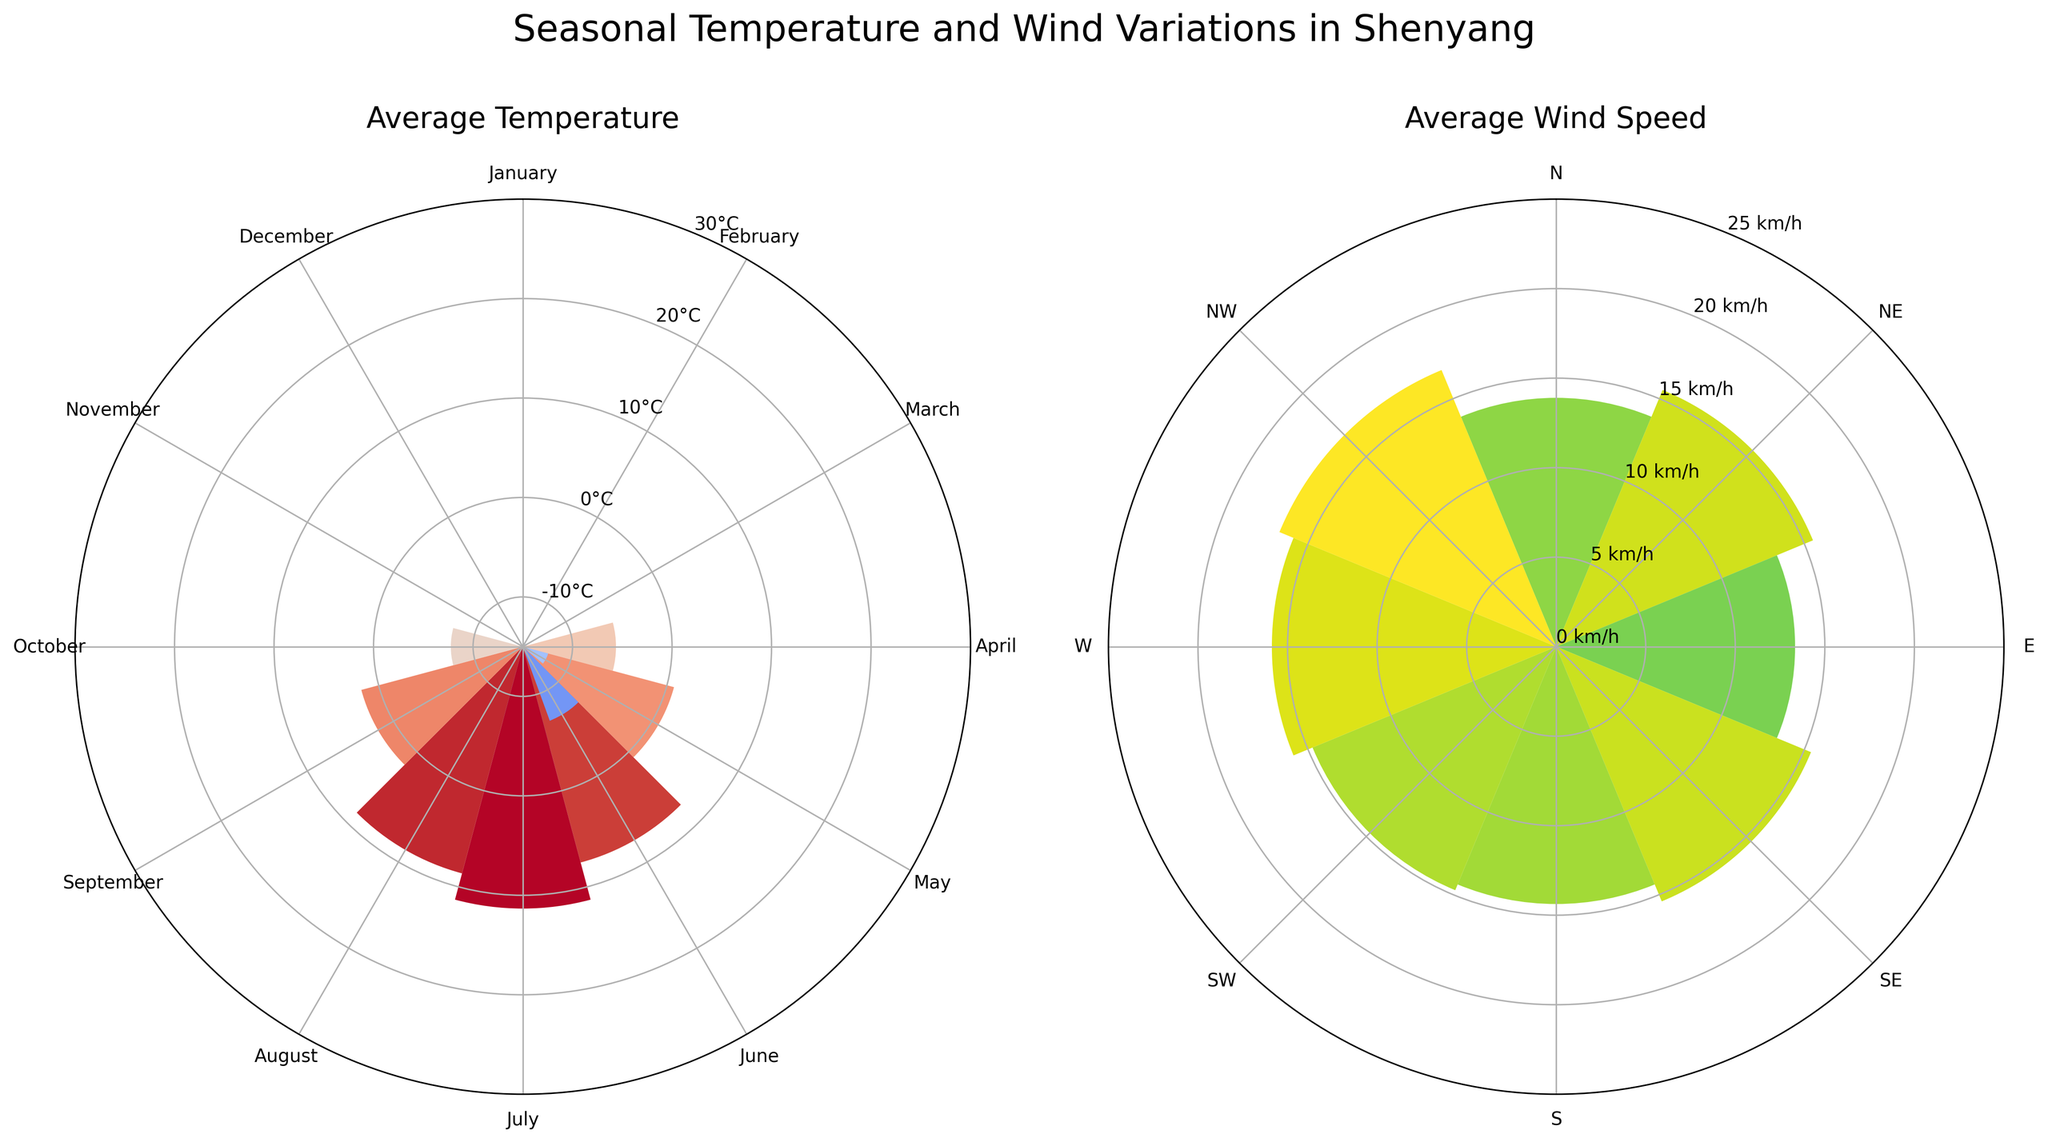What is the title of the figure? The title is located at the top of the figure and is clearly labeled.
Answer: Seasonal Temperature and Wind Variations in Shenyang Which month has the highest average temperature? Looking at the temperature rose chart, July has the longest bar indicating the highest average temperature.
Answer: July What is the average wind speed in the northern direction? Looking at the wind rose chart, the bar for the 'N' direction shows around 14 km/h.
Answer: 14 km/h Which month shows the lowest average temperature? The shortest bar in the temperature rose chart corresponds to January, indicating the lowest average temperature.
Answer: January How many months have an average temperature above 20°C? Identifying bars that exceed the 20°C mark in the temperature rose chart, there are three months: June, July, and August.
Answer: 3 Which direction has the lowest average wind speed? Observing the wind rose chart, the 'S' direction has the shortest bar, indicating the lowest average wind speed.
Answer: S What is the range of average temperatures shown in the temperature rose chart? The range is the difference between the highest and lowest values. From the chart, the highest is around 27°C (July) and the lowest is around -10.5°C (January), giving a range of 37.5°C.
Answer: 37.5°C Which month has the most variation in wind direction? Observing the number of different wind directions for each month, March shows the maximum number of different wind directions with noticeable bars in the wind rose chart.
Answer: March Compare the average wind speeds in March and June. Which month has higher wind speeds? March shows wind speeds around 20 km/h, while June shows wind speeds around 18 km/h in the wind rose chart. March has higher wind speeds.
Answer: March During which month does the direction 'NE' have the highest average wind speed? Checking the bars for NE direction across months in the wind rose chart, January has the highest wind speed in the NE direction.
Answer: January 